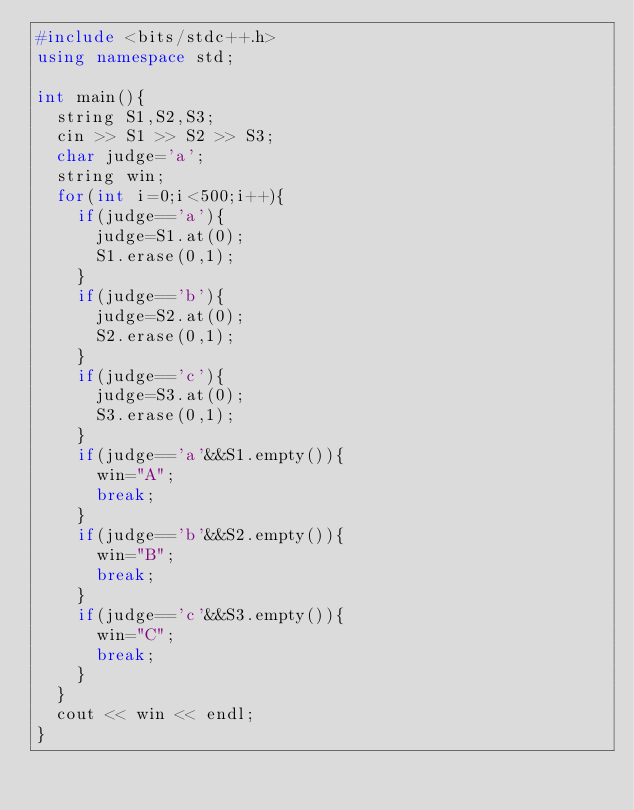Convert code to text. <code><loc_0><loc_0><loc_500><loc_500><_C++_>#include <bits/stdc++.h>
using namespace std;
 
int main(){
  string S1,S2,S3;
  cin >> S1 >> S2 >> S3;
  char judge='a';
  string win;
  for(int i=0;i<500;i++){
    if(judge=='a'){
      judge=S1.at(0);
      S1.erase(0,1);
    }
    if(judge=='b'){
      judge=S2.at(0);
      S2.erase(0,1);
    }
    if(judge=='c'){
      judge=S3.at(0);
      S3.erase(0,1);
    }
    if(judge=='a'&&S1.empty()){
      win="A";
      break;
    }
    if(judge=='b'&&S2.empty()){
      win="B";
      break;
    }
    if(judge=='c'&&S3.empty()){
      win="C";
      break;
    }
  }
  cout << win << endl;
}</code> 